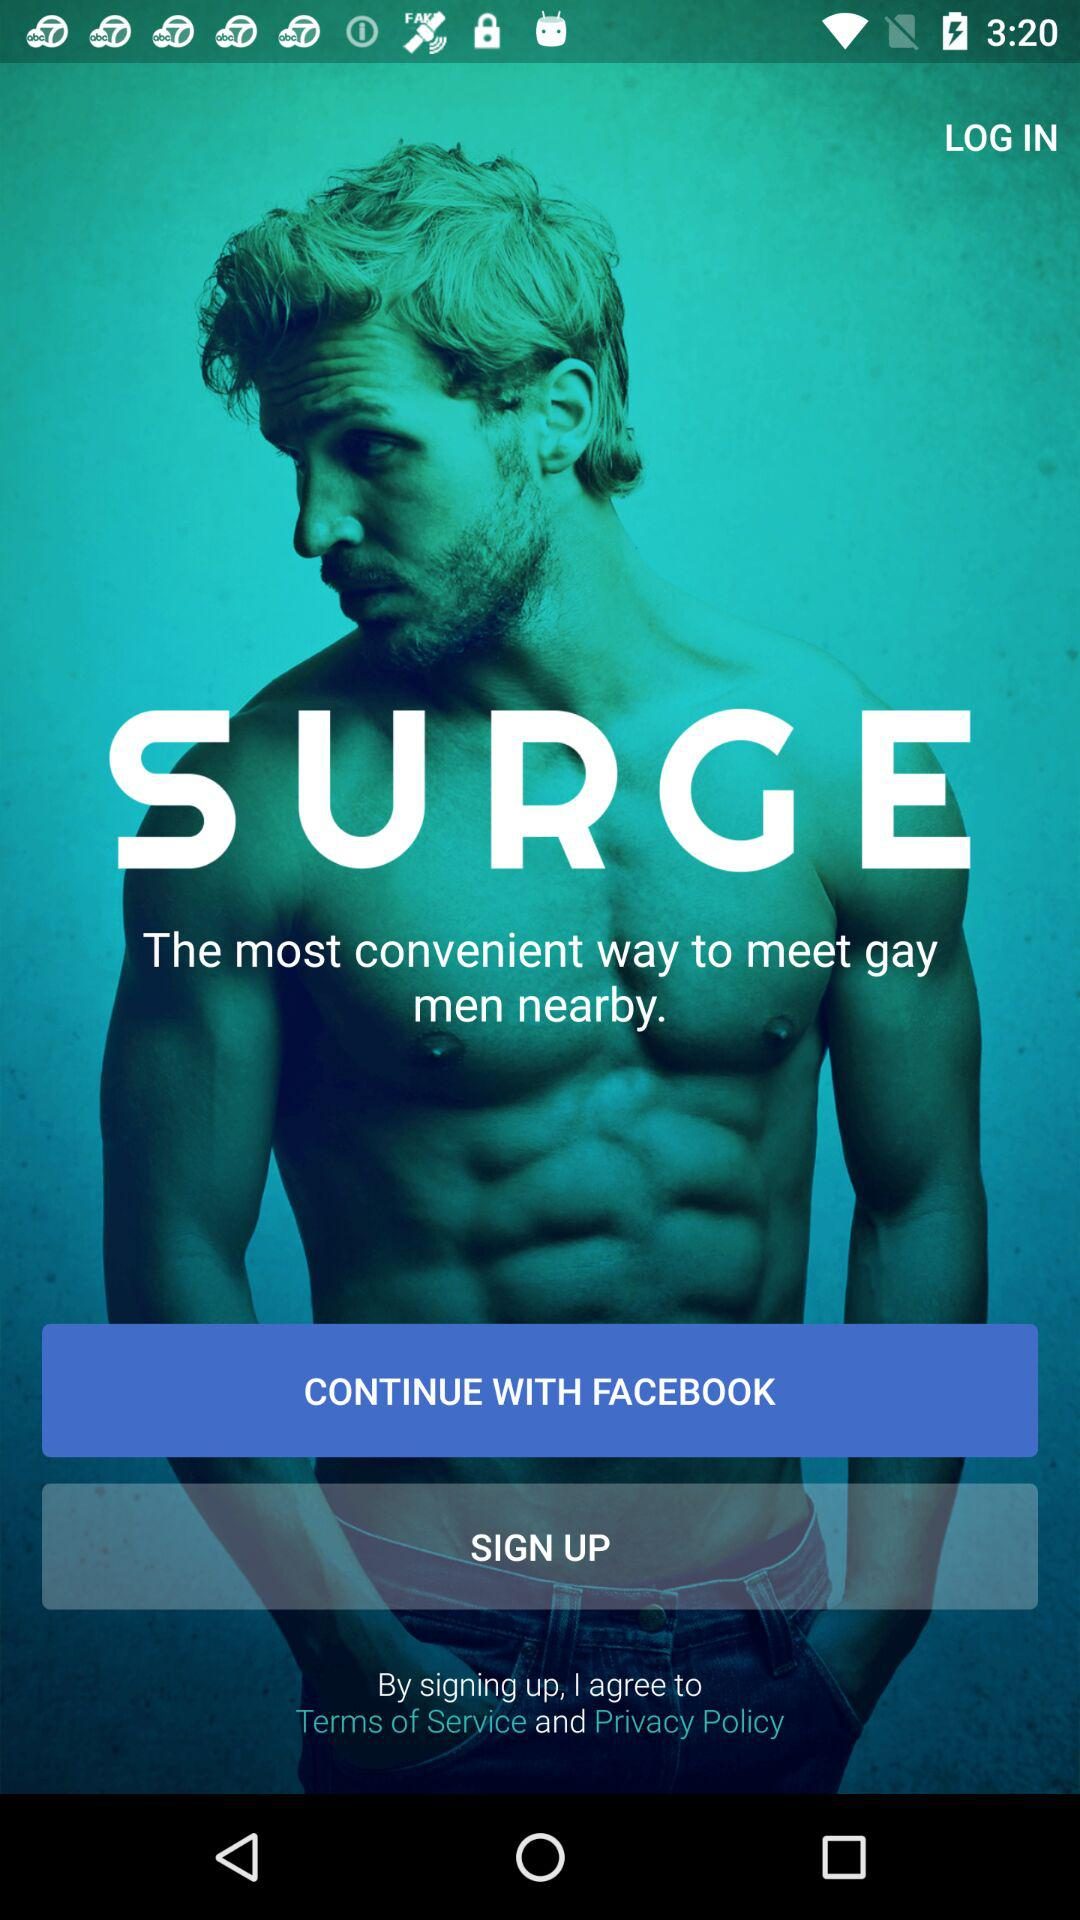What is the name of the application? The name of the application is "SURGE". 